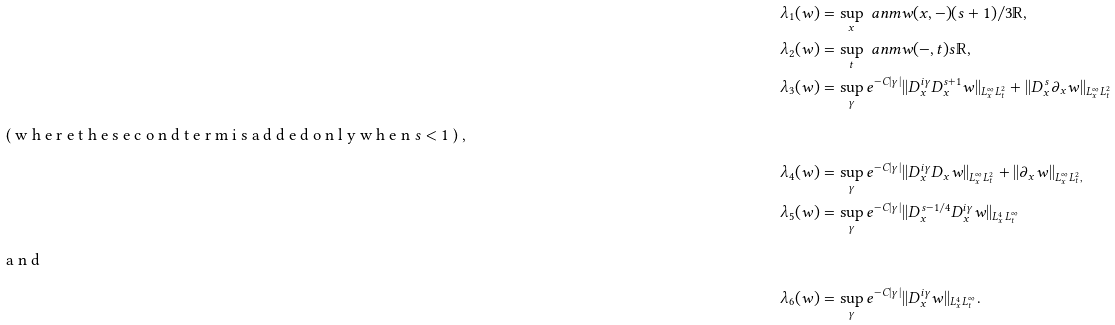Convert formula to latex. <formula><loc_0><loc_0><loc_500><loc_500>\lambda _ { 1 } ( w ) & = \sup _ { x } \ a n m { w ( x , - ) } { ( s + 1 ) / 3 } { \mathbb { R } } , \\ \lambda _ { 2 } ( w ) & = \sup _ { t } \ a n m { w ( - , t ) } { s } { \mathbb { R } } , \\ \lambda _ { 3 } ( w ) & = \sup _ { \gamma } e ^ { - C | \gamma | } | | D _ { x } ^ { i \gamma } D _ { x } ^ { s + 1 } w | | _ { L _ { x } ^ { \infty } L _ { t } ^ { 2 } } + | | D _ { x } ^ { s } \partial _ { x } w | | _ { L _ { x } ^ { \infty } L _ { t } ^ { 2 } } \\ \intertext { ( w h e r e t h e s e c o n d t e r m i s a d d e d o n l y w h e n $ s < 1 $ ) , } \lambda _ { 4 } ( w ) & = \sup _ { \gamma } e ^ { - C | \gamma | } | | D _ { x } ^ { i \gamma } D _ { x } w | | _ { L _ { x } ^ { \infty } L _ { t } ^ { 2 } } + | | \partial _ { x } w | | _ { L _ { x } ^ { \infty } L _ { t } ^ { 2 } , } \\ \lambda _ { 5 } ( w ) & = \sup _ { \gamma } e ^ { - C | \gamma | } | | D _ { x } ^ { s - 1 / 4 } D _ { x } ^ { i \gamma } w | | _ { L _ { x } ^ { 4 } L _ { t } ^ { \infty } } \\ \intertext { a n d } \lambda _ { 6 } ( w ) & = \sup _ { \gamma } e ^ { - C | \gamma | } | | D _ { x } ^ { i \gamma } w | | _ { L _ { x } ^ { 4 } L _ { t } ^ { \infty } } .</formula> 